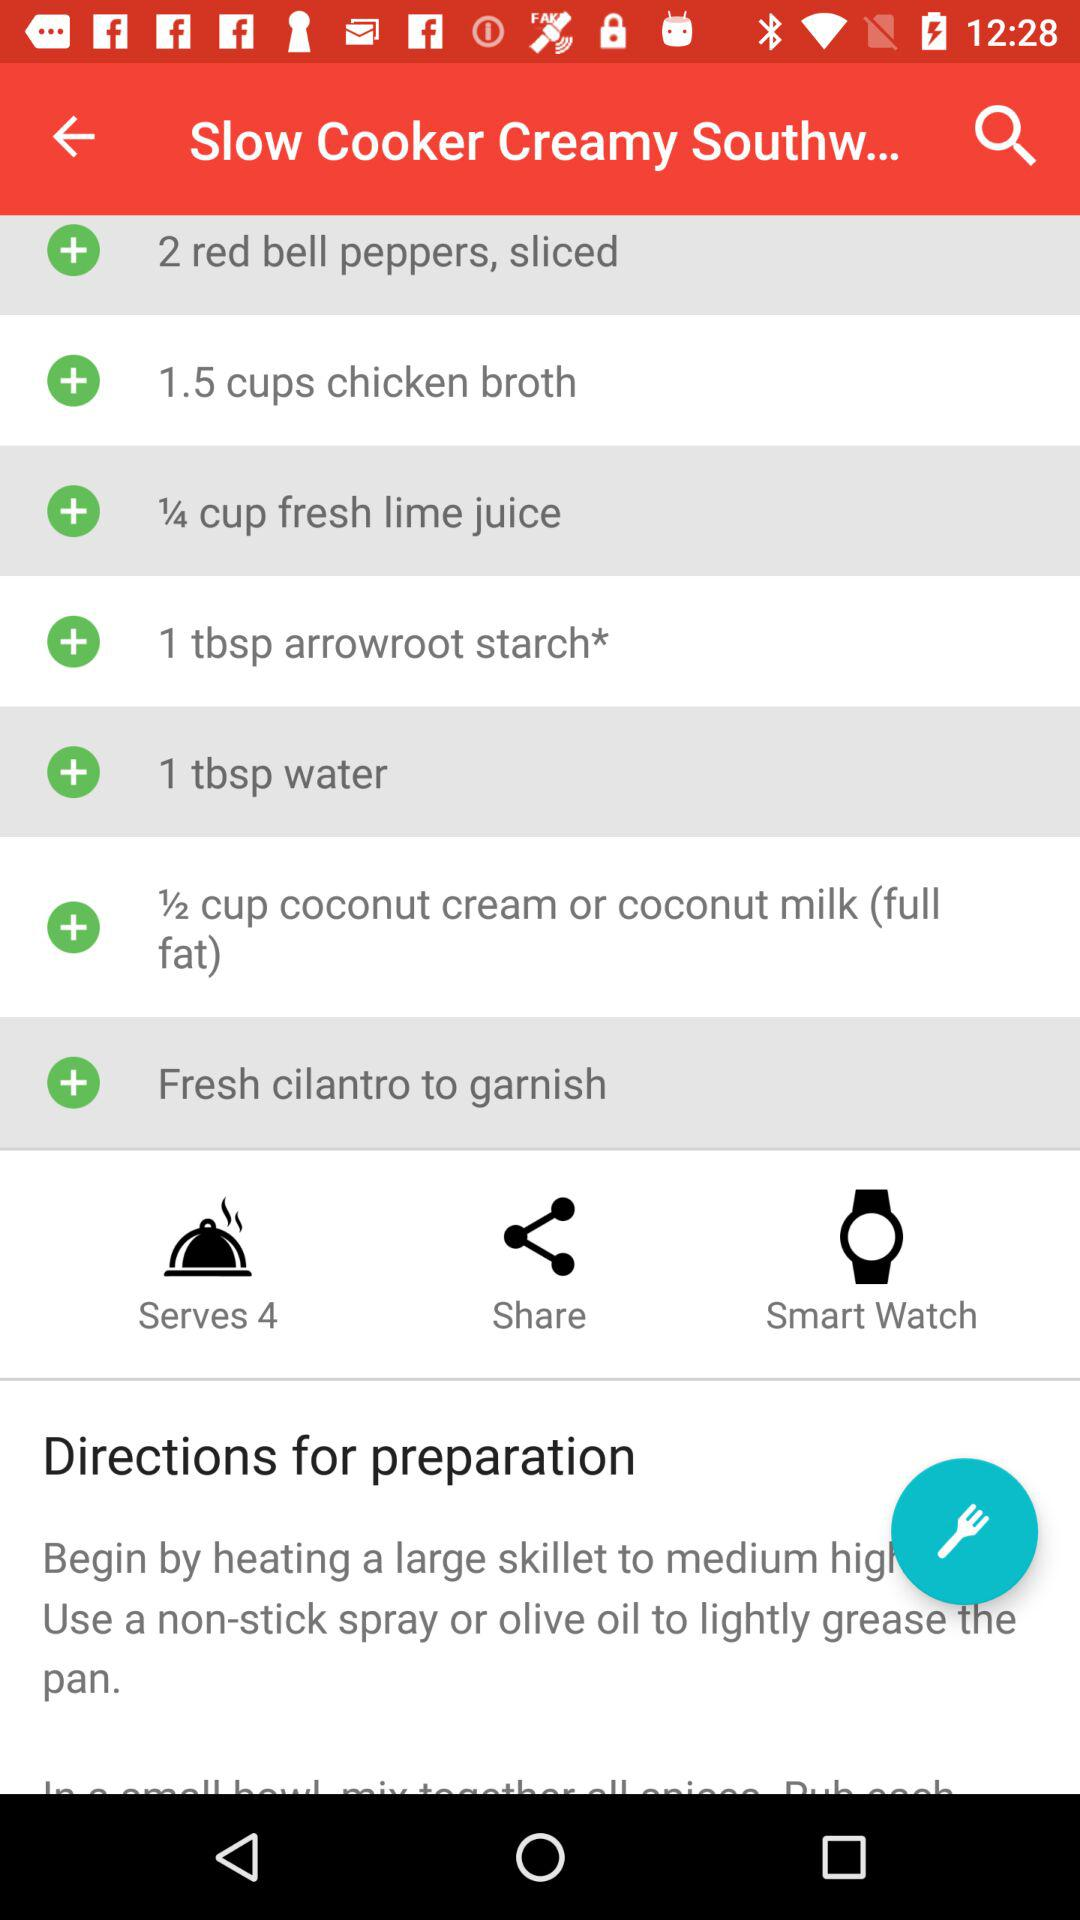What kind of coconut milk is needed? The kind of coconut milk that is needed is full fat. 